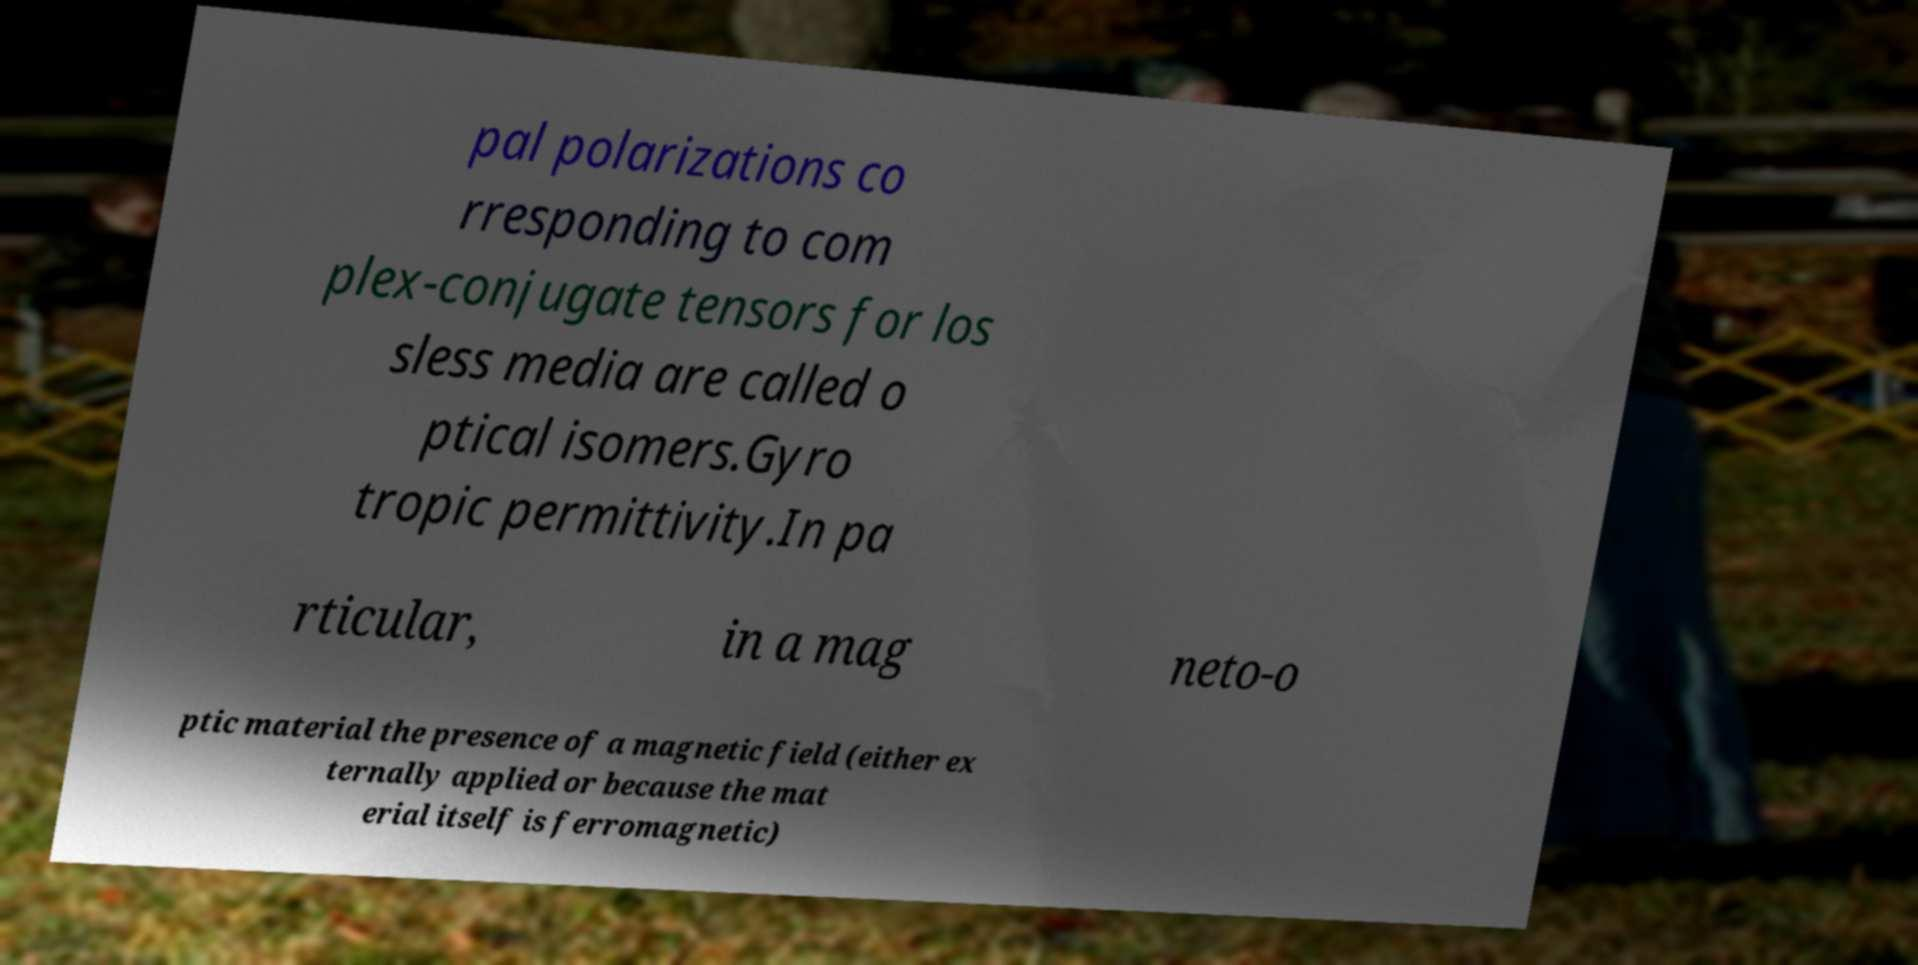There's text embedded in this image that I need extracted. Can you transcribe it verbatim? pal polarizations co rresponding to com plex-conjugate tensors for los sless media are called o ptical isomers.Gyro tropic permittivity.In pa rticular, in a mag neto-o ptic material the presence of a magnetic field (either ex ternally applied or because the mat erial itself is ferromagnetic) 